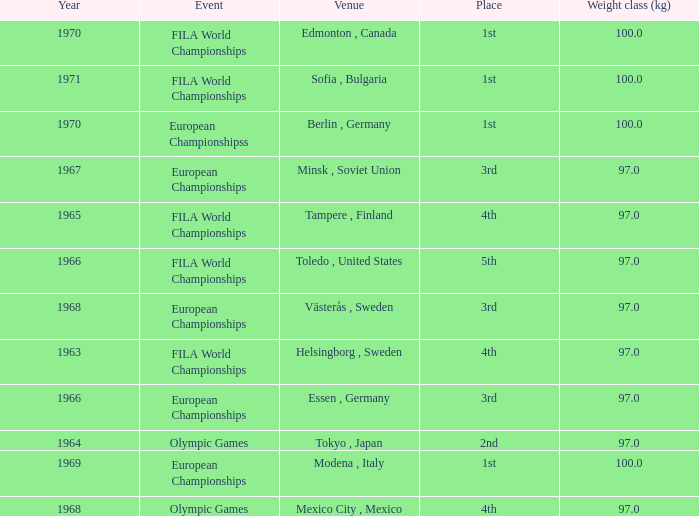What is the lowest year that has edmonton, canada as the venue with a weight class (kg) greater than 100? None. 